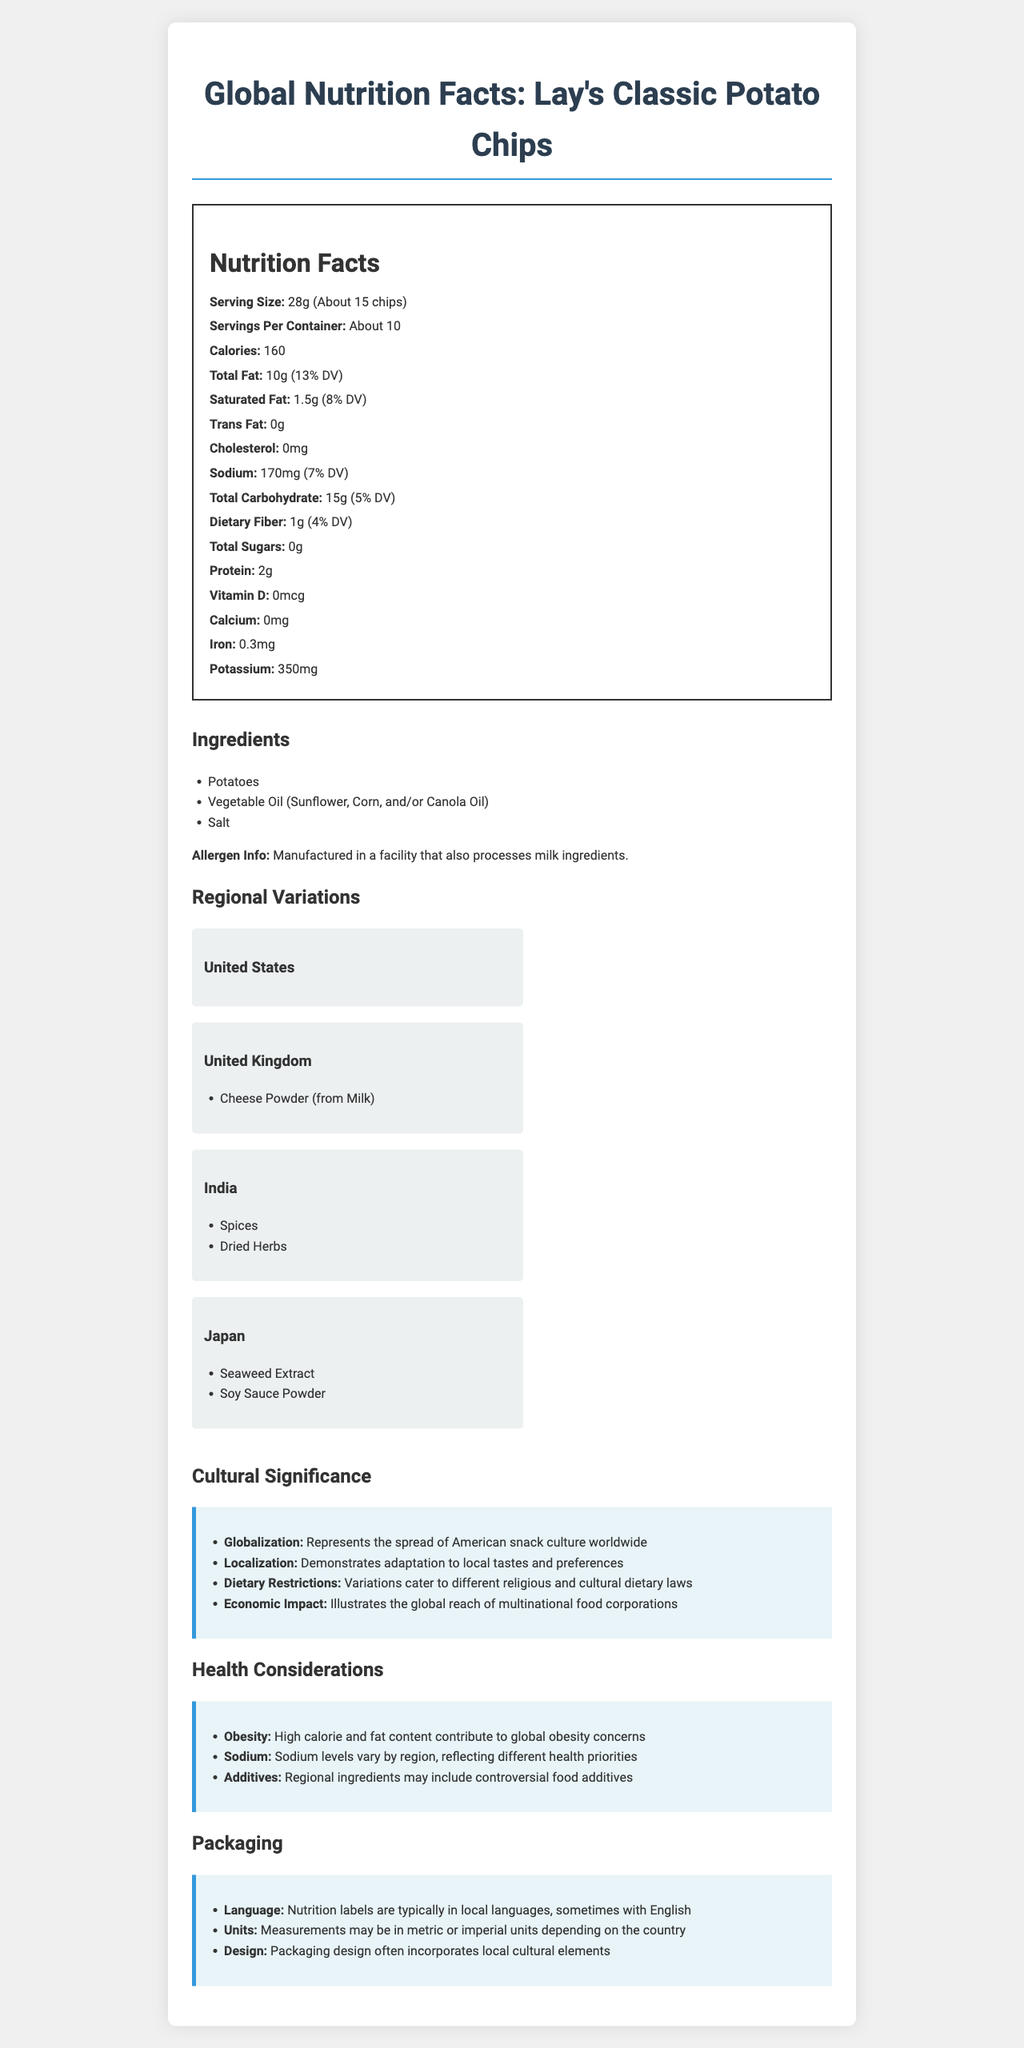which product is the document about? The first line of the document states the product name.
Answer: Lay's Classic Potato Chips what is the serving size? The nutrition facts section provides the serving size information.
Answer: 28g (About 15 chips) how many calories per serving are in Lay's Classic Potato Chips? The nutrition facts indicate that there are 160 calories per serving.
Answer: 160 name two types of oil used in the product. The ingredients list includes "Vegetable Oil (Sunflower, Corn, and/or Canola Oil)".
Answer: Sunflower Oil, Corn Oil what additional ingredient is used in the United Kingdom version? The regional variations section states that the United Kingdom has cheese powder (from milk).
Answer: Cheese Powder (from Milk) which country adds spices and dried herbs to their Lay's chips? The regional variations section indicates that in India, spices and dried herbs are added.
Answer: India how much iron is in one serving? The nutrition facts section lists iron as 0.3mg per serving.
Answer: 0.3mg is there any cholesterol in Lay's Classic Potato Chips? The document specifies that the cholesterol content is 0mg.
Answer: No choose the correct statement: A. Lay's chips in Japan contain seaweed extract. B. Lay's chips in India have soy sauce powder. C. Lay's chips in the United States have additional spices. The regional variations section indicates that Japan uses seaweed extract in their version of Lay's chips.
Answer: A which of the following best describes the packaging observances in the document? A. All units are in metric. B. The language is consistent globally. C. Packaging design often incorporates local cultural elements. The packaging section mentions that packaging design often incorporates local cultural elements.
Answer: C does the document mention any health considerations related to obesity? The health considerations section lists "obesity" as a consideration.
Answer: Yes summarize the cultural significance section. The section details how Lay's reflects globalization and localization, caters to dietary laws, and shows the economic impact of multinational corporations.
Answer: Represents the spread of American snack culture worldwide, demonstrates adaptation to local tastes and preferences, caters to different religious and cultural dietary laws, illustrates the global reach of multinational food corporations. how does the document describe differences in sodium levels by region? The health considerations section explains that sodium levels vary according to regional health priorities.
Answer: Sodium levels vary by region, reflecting different health priorities which ingredient is common across all regional variations? The ingredients section lists potatoes as the primary ingredient, and no regional variation mentions the removal of potatoes.
Answer: Potatoes what is the daily value percentage of saturated fat per serving? The nutrition facts section lists the daily value percentage for saturated fat as 8%.
Answer: 8% in which section does it mention the economic impact of Lay's? The cultural significance section includes a point on the economic impact.
Answer: Cultural Significance what kind of oil could be used in Lay's Classic Potato Chips? A. Olive Oil B. Canola Oil C. Peanut Oil D. Palm Oil The included oils are Sunflower, Corn, and/or Canola Oil.
Answer: B which regional variation is uniquely modified with seaweed extract? The regional variations section lists seaweed extract for Japan.
Answer: Japan how is sodium represented differently by region according to health priorities? The health considerations section discusses this variance.
Answer: Sodium levels vary by region, reflecting different health priorities why is it difficult to determine the specific additives used in each region? The document does not provide a detailed list of all food additives used in every regional variation.
Answer: Cannot be determined describe the packaging differences according to the document. The packaging section details these differences in language, units, and design.
Answer: Language varies, measurement units may be metric or imperial, design incorporates local cultural elements 